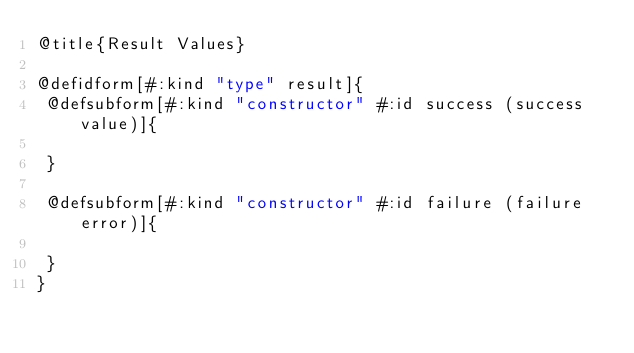<code> <loc_0><loc_0><loc_500><loc_500><_Racket_>@title{Result Values}

@defidform[#:kind "type" result]{
 @defsubform[#:kind "constructor" #:id success (success value)]{

 }

 @defsubform[#:kind "constructor" #:id failure (failure error)]{

 }
}
</code> 